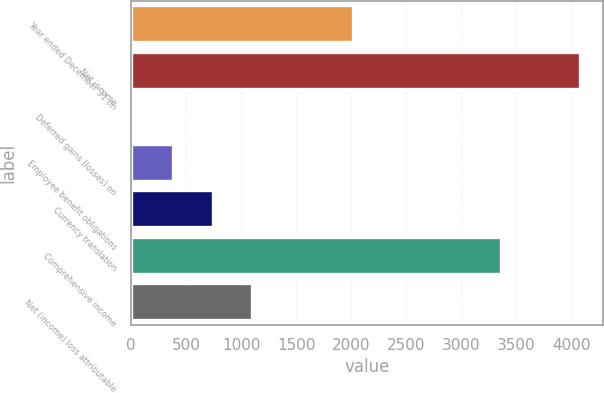Convert chart. <chart><loc_0><loc_0><loc_500><loc_500><bar_chart><fcel>Year ended December 31 (in<fcel>Net income<fcel>Deferred gains (losses) on<fcel>Employee benefit obligations<fcel>Currency translation<fcel>Comprehensive income<fcel>Net (income) loss attributable<nl><fcel>2015<fcel>4081.6<fcel>21<fcel>381.3<fcel>741.6<fcel>3361<fcel>1101.9<nl></chart> 